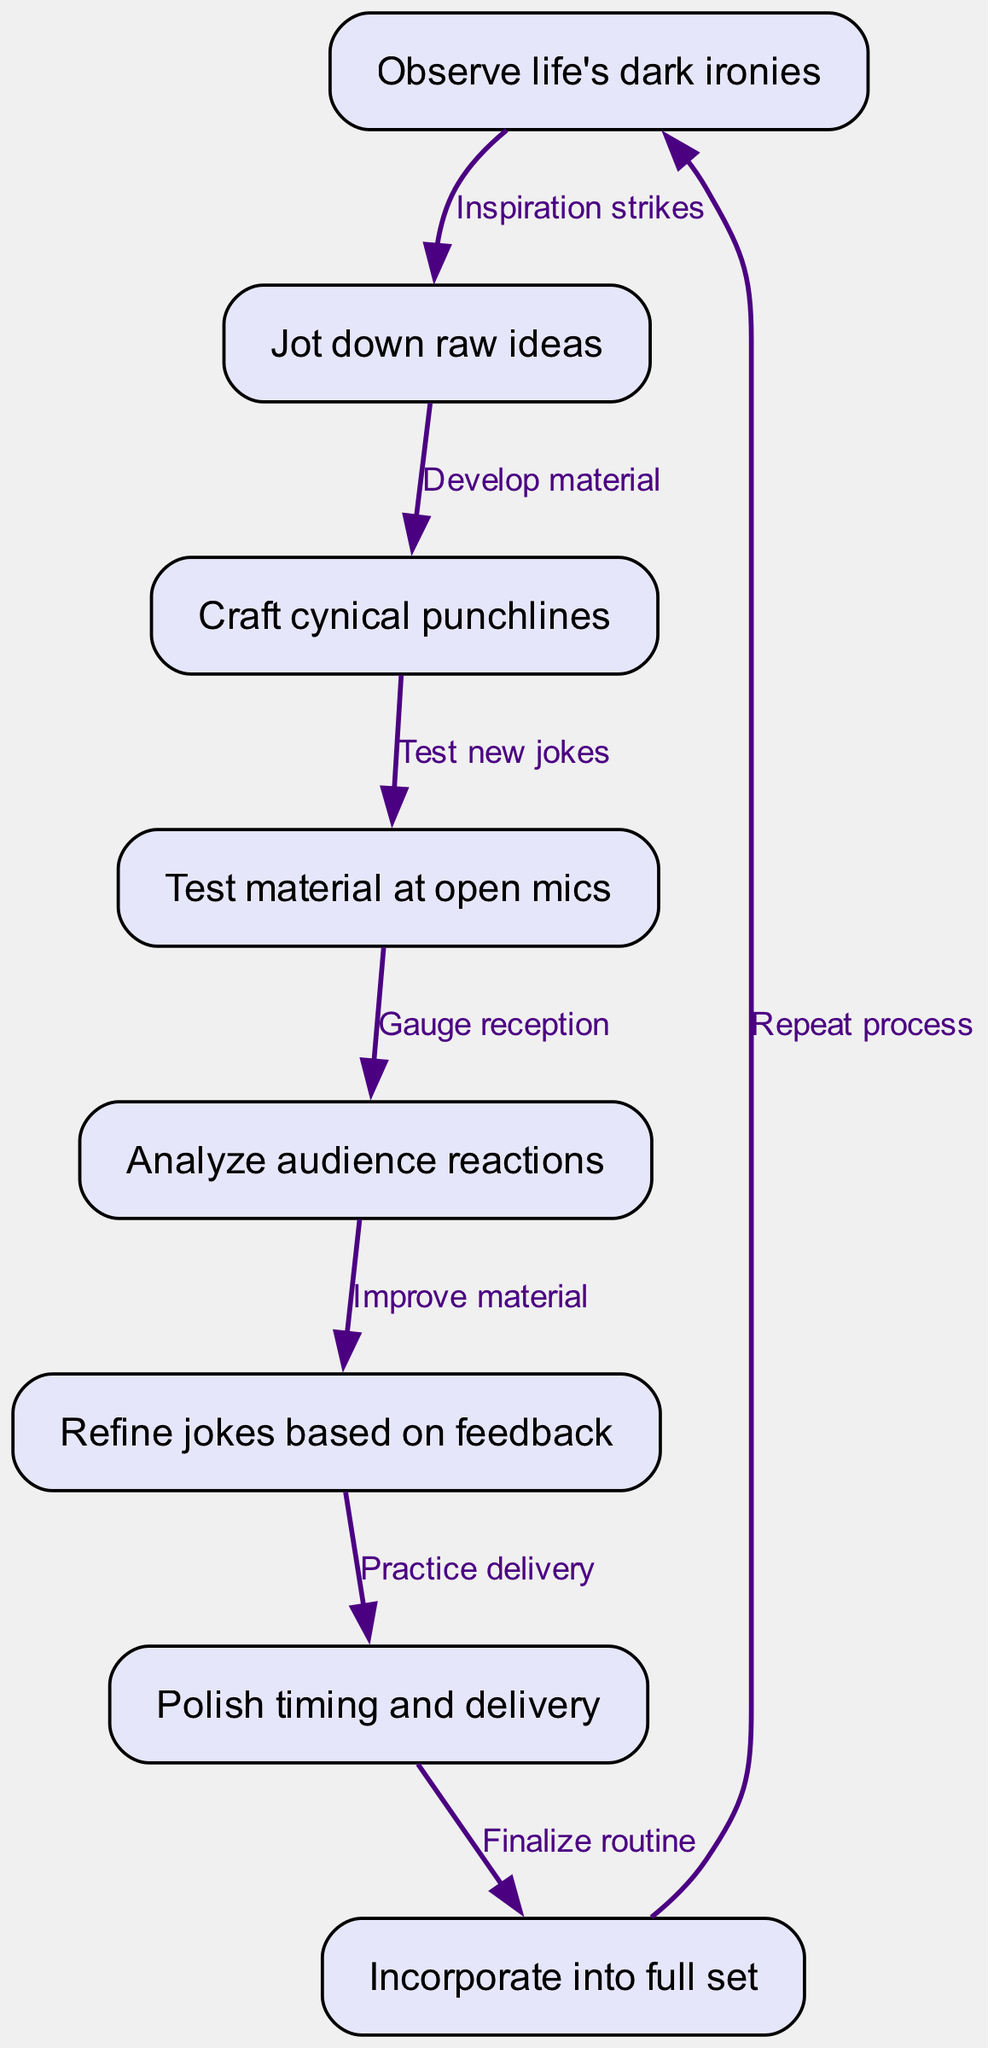What is the first step in the flowchart? The first node in the flowchart is labeled "Observe life's dark ironies," which signifies the initial step where a comedian finds inspiration.
Answer: Observe life's dark ironies How many nodes are in the diagram? The diagram contains eight nodes, each representing a specific step in the process of developing a stand-up comedy routine.
Answer: 8 Which step comes after testing material at open mics? After "Test material at open mics," the next step is "Analyze audience reactions," which reflects evaluating the performance feedback from the audience.
Answer: Analyze audience reactions What do you do after refining jokes based on feedback? Following the refinement of jokes based on feedback, the next step is to "Polish timing and delivery," emphasizing the importance of how the jokes are presented.
Answer: Polish timing and delivery What is the relationship between observing life's dark ironies and jotting down raw ideas? The relationship is described as "Inspiration strikes," indicating that noting raw ideas is inspired by the initial observation of life's dark humor.
Answer: Inspiration strikes What step involves audience feedback? The step that involves audience feedback is "Analyze audience reactions," where the performer takes note of how the audience responded to the material presented.
Answer: Analyze audience reactions How many edges are present connecting the nodes? The diagram has seven edges that connect the eight nodes, illustrating the flow of steps in developing the comedy routine.
Answer: 7 What is the final action in the flowchart before it loops back to the beginning? The final action before looping back is "Incorporate into full set," which implies integrating refined jokes into the overall performance.
Answer: Incorporate into full set 